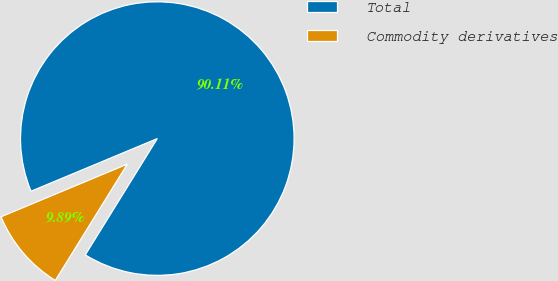Convert chart. <chart><loc_0><loc_0><loc_500><loc_500><pie_chart><fcel>Total<fcel>Commodity derivatives<nl><fcel>90.11%<fcel>9.89%<nl></chart> 